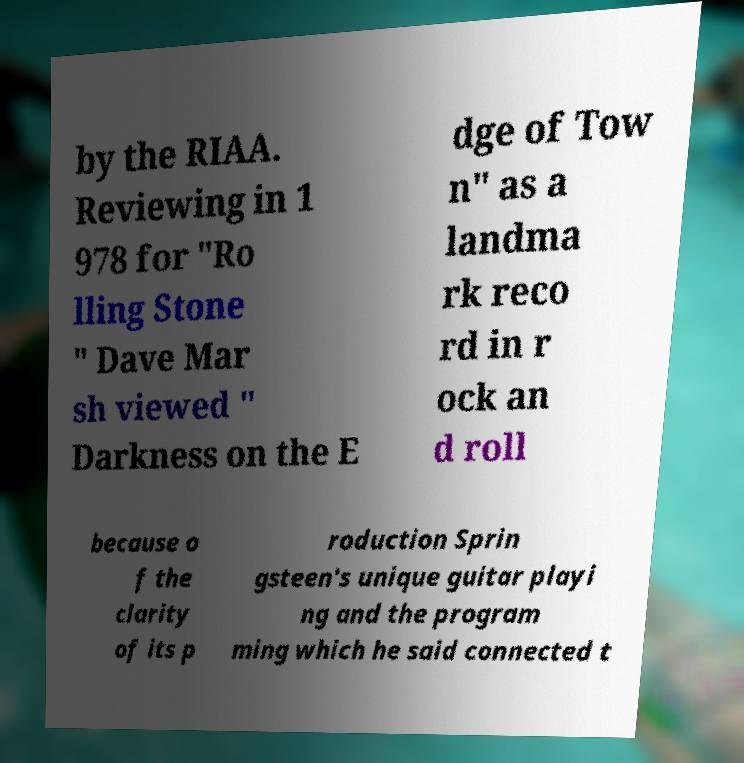Could you assist in decoding the text presented in this image and type it out clearly? by the RIAA. Reviewing in 1 978 for "Ro lling Stone " Dave Mar sh viewed " Darkness on the E dge of Tow n" as a landma rk reco rd in r ock an d roll because o f the clarity of its p roduction Sprin gsteen's unique guitar playi ng and the program ming which he said connected t 